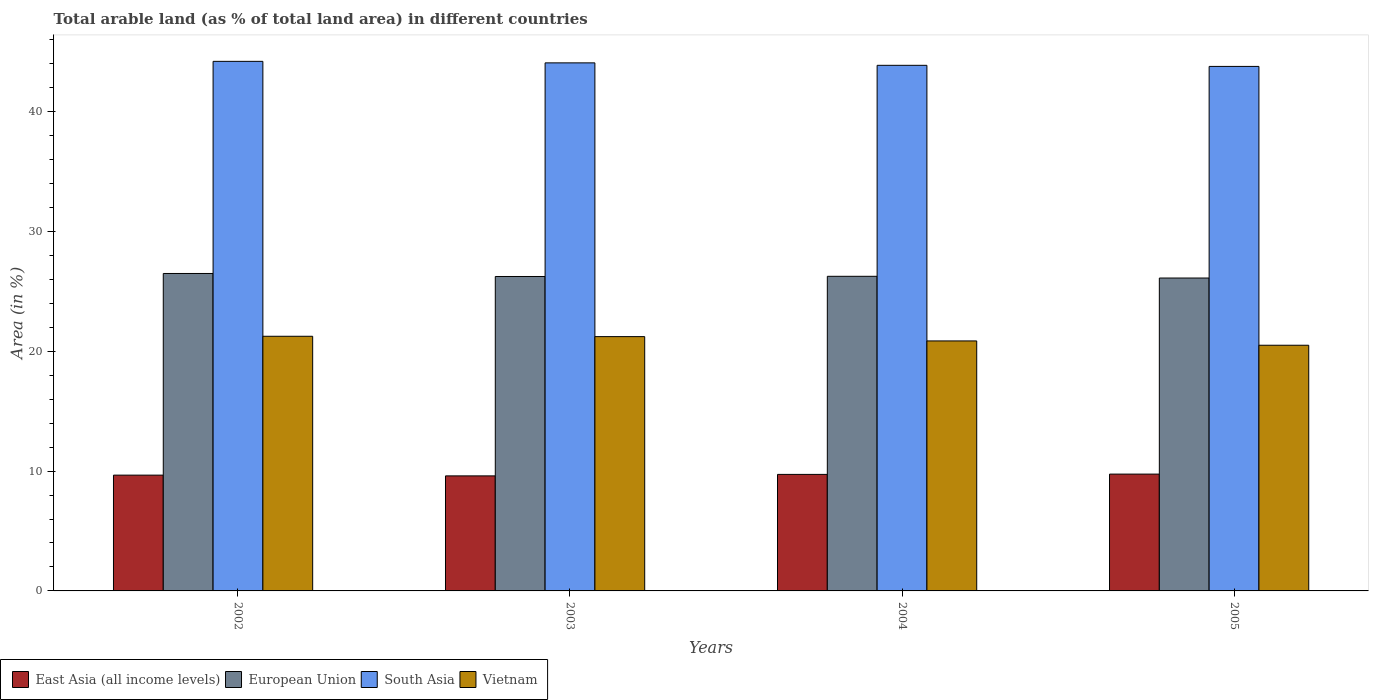How many different coloured bars are there?
Offer a very short reply. 4. How many groups of bars are there?
Keep it short and to the point. 4. Are the number of bars per tick equal to the number of legend labels?
Make the answer very short. Yes. How many bars are there on the 1st tick from the left?
Offer a very short reply. 4. What is the label of the 1st group of bars from the left?
Make the answer very short. 2002. What is the percentage of arable land in European Union in 2002?
Ensure brevity in your answer.  26.49. Across all years, what is the maximum percentage of arable land in Vietnam?
Provide a succinct answer. 21.25. Across all years, what is the minimum percentage of arable land in East Asia (all income levels)?
Offer a very short reply. 9.6. What is the total percentage of arable land in Vietnam in the graph?
Keep it short and to the point. 83.85. What is the difference between the percentage of arable land in East Asia (all income levels) in 2003 and that in 2005?
Your response must be concise. -0.15. What is the difference between the percentage of arable land in Vietnam in 2003 and the percentage of arable land in European Union in 2004?
Provide a short and direct response. -5.03. What is the average percentage of arable land in East Asia (all income levels) per year?
Keep it short and to the point. 9.69. In the year 2005, what is the difference between the percentage of arable land in East Asia (all income levels) and percentage of arable land in South Asia?
Give a very brief answer. -34.03. What is the ratio of the percentage of arable land in European Union in 2003 to that in 2005?
Your answer should be very brief. 1. Is the percentage of arable land in South Asia in 2002 less than that in 2005?
Keep it short and to the point. No. Is the difference between the percentage of arable land in East Asia (all income levels) in 2004 and 2005 greater than the difference between the percentage of arable land in South Asia in 2004 and 2005?
Your answer should be compact. No. What is the difference between the highest and the second highest percentage of arable land in South Asia?
Ensure brevity in your answer.  0.13. What is the difference between the highest and the lowest percentage of arable land in European Union?
Your response must be concise. 0.38. What does the 4th bar from the left in 2002 represents?
Keep it short and to the point. Vietnam. Is it the case that in every year, the sum of the percentage of arable land in Vietnam and percentage of arable land in East Asia (all income levels) is greater than the percentage of arable land in European Union?
Your answer should be very brief. Yes. How many bars are there?
Your answer should be compact. 16. Are all the bars in the graph horizontal?
Offer a very short reply. No. How many years are there in the graph?
Your answer should be very brief. 4. What is the difference between two consecutive major ticks on the Y-axis?
Keep it short and to the point. 10. Does the graph contain any zero values?
Your response must be concise. No. Where does the legend appear in the graph?
Make the answer very short. Bottom left. How many legend labels are there?
Keep it short and to the point. 4. What is the title of the graph?
Provide a succinct answer. Total arable land (as % of total land area) in different countries. What is the label or title of the Y-axis?
Give a very brief answer. Area (in %). What is the Area (in %) of East Asia (all income levels) in 2002?
Your answer should be compact. 9.66. What is the Area (in %) of European Union in 2002?
Offer a very short reply. 26.49. What is the Area (in %) of South Asia in 2002?
Ensure brevity in your answer.  44.2. What is the Area (in %) in Vietnam in 2002?
Give a very brief answer. 21.25. What is the Area (in %) in East Asia (all income levels) in 2003?
Offer a very short reply. 9.6. What is the Area (in %) of European Union in 2003?
Give a very brief answer. 26.24. What is the Area (in %) in South Asia in 2003?
Give a very brief answer. 44.07. What is the Area (in %) in Vietnam in 2003?
Provide a short and direct response. 21.22. What is the Area (in %) in East Asia (all income levels) in 2004?
Keep it short and to the point. 9.72. What is the Area (in %) in European Union in 2004?
Your response must be concise. 26.26. What is the Area (in %) in South Asia in 2004?
Your answer should be very brief. 43.87. What is the Area (in %) of Vietnam in 2004?
Ensure brevity in your answer.  20.86. What is the Area (in %) of East Asia (all income levels) in 2005?
Offer a very short reply. 9.75. What is the Area (in %) of European Union in 2005?
Give a very brief answer. 26.11. What is the Area (in %) of South Asia in 2005?
Keep it short and to the point. 43.78. What is the Area (in %) of Vietnam in 2005?
Your answer should be very brief. 20.51. Across all years, what is the maximum Area (in %) in East Asia (all income levels)?
Ensure brevity in your answer.  9.75. Across all years, what is the maximum Area (in %) of European Union?
Offer a terse response. 26.49. Across all years, what is the maximum Area (in %) in South Asia?
Make the answer very short. 44.2. Across all years, what is the maximum Area (in %) of Vietnam?
Give a very brief answer. 21.25. Across all years, what is the minimum Area (in %) of East Asia (all income levels)?
Your response must be concise. 9.6. Across all years, what is the minimum Area (in %) of European Union?
Offer a terse response. 26.11. Across all years, what is the minimum Area (in %) of South Asia?
Your answer should be compact. 43.78. Across all years, what is the minimum Area (in %) in Vietnam?
Make the answer very short. 20.51. What is the total Area (in %) in East Asia (all income levels) in the graph?
Your answer should be compact. 38.74. What is the total Area (in %) of European Union in the graph?
Keep it short and to the point. 105.11. What is the total Area (in %) in South Asia in the graph?
Your answer should be compact. 175.91. What is the total Area (in %) of Vietnam in the graph?
Ensure brevity in your answer.  83.85. What is the difference between the Area (in %) in East Asia (all income levels) in 2002 and that in 2003?
Your response must be concise. 0.06. What is the difference between the Area (in %) in European Union in 2002 and that in 2003?
Keep it short and to the point. 0.25. What is the difference between the Area (in %) in South Asia in 2002 and that in 2003?
Your response must be concise. 0.13. What is the difference between the Area (in %) of Vietnam in 2002 and that in 2003?
Your response must be concise. 0.03. What is the difference between the Area (in %) in East Asia (all income levels) in 2002 and that in 2004?
Your answer should be very brief. -0.06. What is the difference between the Area (in %) of European Union in 2002 and that in 2004?
Your answer should be compact. 0.24. What is the difference between the Area (in %) of South Asia in 2002 and that in 2004?
Provide a short and direct response. 0.33. What is the difference between the Area (in %) of Vietnam in 2002 and that in 2004?
Your answer should be compact. 0.39. What is the difference between the Area (in %) in East Asia (all income levels) in 2002 and that in 2005?
Your answer should be very brief. -0.09. What is the difference between the Area (in %) in European Union in 2002 and that in 2005?
Give a very brief answer. 0.38. What is the difference between the Area (in %) in South Asia in 2002 and that in 2005?
Provide a succinct answer. 0.42. What is the difference between the Area (in %) of Vietnam in 2002 and that in 2005?
Ensure brevity in your answer.  0.75. What is the difference between the Area (in %) of East Asia (all income levels) in 2003 and that in 2004?
Give a very brief answer. -0.12. What is the difference between the Area (in %) of European Union in 2003 and that in 2004?
Keep it short and to the point. -0.02. What is the difference between the Area (in %) of South Asia in 2003 and that in 2004?
Provide a short and direct response. 0.21. What is the difference between the Area (in %) of Vietnam in 2003 and that in 2004?
Ensure brevity in your answer.  0.36. What is the difference between the Area (in %) in East Asia (all income levels) in 2003 and that in 2005?
Offer a very short reply. -0.15. What is the difference between the Area (in %) in European Union in 2003 and that in 2005?
Provide a short and direct response. 0.13. What is the difference between the Area (in %) of South Asia in 2003 and that in 2005?
Provide a succinct answer. 0.3. What is the difference between the Area (in %) of Vietnam in 2003 and that in 2005?
Keep it short and to the point. 0.72. What is the difference between the Area (in %) in East Asia (all income levels) in 2004 and that in 2005?
Offer a terse response. -0.03. What is the difference between the Area (in %) of European Union in 2004 and that in 2005?
Ensure brevity in your answer.  0.14. What is the difference between the Area (in %) of South Asia in 2004 and that in 2005?
Keep it short and to the point. 0.09. What is the difference between the Area (in %) of Vietnam in 2004 and that in 2005?
Give a very brief answer. 0.36. What is the difference between the Area (in %) of East Asia (all income levels) in 2002 and the Area (in %) of European Union in 2003?
Provide a short and direct response. -16.58. What is the difference between the Area (in %) in East Asia (all income levels) in 2002 and the Area (in %) in South Asia in 2003?
Your answer should be very brief. -34.41. What is the difference between the Area (in %) of East Asia (all income levels) in 2002 and the Area (in %) of Vietnam in 2003?
Offer a very short reply. -11.56. What is the difference between the Area (in %) in European Union in 2002 and the Area (in %) in South Asia in 2003?
Keep it short and to the point. -17.58. What is the difference between the Area (in %) in European Union in 2002 and the Area (in %) in Vietnam in 2003?
Keep it short and to the point. 5.27. What is the difference between the Area (in %) in South Asia in 2002 and the Area (in %) in Vietnam in 2003?
Offer a very short reply. 22.97. What is the difference between the Area (in %) of East Asia (all income levels) in 2002 and the Area (in %) of European Union in 2004?
Your response must be concise. -16.59. What is the difference between the Area (in %) of East Asia (all income levels) in 2002 and the Area (in %) of South Asia in 2004?
Ensure brevity in your answer.  -34.2. What is the difference between the Area (in %) in East Asia (all income levels) in 2002 and the Area (in %) in Vietnam in 2004?
Your answer should be very brief. -11.2. What is the difference between the Area (in %) in European Union in 2002 and the Area (in %) in South Asia in 2004?
Provide a short and direct response. -17.37. What is the difference between the Area (in %) in European Union in 2002 and the Area (in %) in Vietnam in 2004?
Give a very brief answer. 5.63. What is the difference between the Area (in %) of South Asia in 2002 and the Area (in %) of Vietnam in 2004?
Ensure brevity in your answer.  23.33. What is the difference between the Area (in %) of East Asia (all income levels) in 2002 and the Area (in %) of European Union in 2005?
Your response must be concise. -16.45. What is the difference between the Area (in %) in East Asia (all income levels) in 2002 and the Area (in %) in South Asia in 2005?
Your answer should be very brief. -34.11. What is the difference between the Area (in %) in East Asia (all income levels) in 2002 and the Area (in %) in Vietnam in 2005?
Your response must be concise. -10.84. What is the difference between the Area (in %) in European Union in 2002 and the Area (in %) in South Asia in 2005?
Make the answer very short. -17.28. What is the difference between the Area (in %) in European Union in 2002 and the Area (in %) in Vietnam in 2005?
Your answer should be compact. 5.99. What is the difference between the Area (in %) of South Asia in 2002 and the Area (in %) of Vietnam in 2005?
Offer a terse response. 23.69. What is the difference between the Area (in %) in East Asia (all income levels) in 2003 and the Area (in %) in European Union in 2004?
Offer a very short reply. -16.66. What is the difference between the Area (in %) in East Asia (all income levels) in 2003 and the Area (in %) in South Asia in 2004?
Keep it short and to the point. -34.26. What is the difference between the Area (in %) in East Asia (all income levels) in 2003 and the Area (in %) in Vietnam in 2004?
Your answer should be very brief. -11.26. What is the difference between the Area (in %) in European Union in 2003 and the Area (in %) in South Asia in 2004?
Ensure brevity in your answer.  -17.62. What is the difference between the Area (in %) in European Union in 2003 and the Area (in %) in Vietnam in 2004?
Your answer should be very brief. 5.38. What is the difference between the Area (in %) of South Asia in 2003 and the Area (in %) of Vietnam in 2004?
Offer a terse response. 23.21. What is the difference between the Area (in %) of East Asia (all income levels) in 2003 and the Area (in %) of European Union in 2005?
Offer a terse response. -16.51. What is the difference between the Area (in %) in East Asia (all income levels) in 2003 and the Area (in %) in South Asia in 2005?
Ensure brevity in your answer.  -34.17. What is the difference between the Area (in %) of East Asia (all income levels) in 2003 and the Area (in %) of Vietnam in 2005?
Your answer should be very brief. -10.9. What is the difference between the Area (in %) of European Union in 2003 and the Area (in %) of South Asia in 2005?
Ensure brevity in your answer.  -17.53. What is the difference between the Area (in %) of European Union in 2003 and the Area (in %) of Vietnam in 2005?
Your answer should be very brief. 5.74. What is the difference between the Area (in %) of South Asia in 2003 and the Area (in %) of Vietnam in 2005?
Offer a very short reply. 23.57. What is the difference between the Area (in %) in East Asia (all income levels) in 2004 and the Area (in %) in European Union in 2005?
Your response must be concise. -16.39. What is the difference between the Area (in %) of East Asia (all income levels) in 2004 and the Area (in %) of South Asia in 2005?
Your answer should be compact. -34.05. What is the difference between the Area (in %) of East Asia (all income levels) in 2004 and the Area (in %) of Vietnam in 2005?
Give a very brief answer. -10.78. What is the difference between the Area (in %) of European Union in 2004 and the Area (in %) of South Asia in 2005?
Offer a very short reply. -17.52. What is the difference between the Area (in %) of European Union in 2004 and the Area (in %) of Vietnam in 2005?
Your answer should be very brief. 5.75. What is the difference between the Area (in %) of South Asia in 2004 and the Area (in %) of Vietnam in 2005?
Keep it short and to the point. 23.36. What is the average Area (in %) of East Asia (all income levels) per year?
Your answer should be compact. 9.69. What is the average Area (in %) in European Union per year?
Offer a very short reply. 26.28. What is the average Area (in %) in South Asia per year?
Provide a short and direct response. 43.98. What is the average Area (in %) of Vietnam per year?
Keep it short and to the point. 20.96. In the year 2002, what is the difference between the Area (in %) in East Asia (all income levels) and Area (in %) in European Union?
Keep it short and to the point. -16.83. In the year 2002, what is the difference between the Area (in %) of East Asia (all income levels) and Area (in %) of South Asia?
Provide a short and direct response. -34.53. In the year 2002, what is the difference between the Area (in %) in East Asia (all income levels) and Area (in %) in Vietnam?
Your response must be concise. -11.59. In the year 2002, what is the difference between the Area (in %) of European Union and Area (in %) of South Asia?
Your answer should be compact. -17.7. In the year 2002, what is the difference between the Area (in %) in European Union and Area (in %) in Vietnam?
Provide a succinct answer. 5.24. In the year 2002, what is the difference between the Area (in %) in South Asia and Area (in %) in Vietnam?
Offer a terse response. 22.95. In the year 2003, what is the difference between the Area (in %) in East Asia (all income levels) and Area (in %) in European Union?
Your answer should be compact. -16.64. In the year 2003, what is the difference between the Area (in %) of East Asia (all income levels) and Area (in %) of South Asia?
Offer a terse response. -34.47. In the year 2003, what is the difference between the Area (in %) in East Asia (all income levels) and Area (in %) in Vietnam?
Make the answer very short. -11.62. In the year 2003, what is the difference between the Area (in %) in European Union and Area (in %) in South Asia?
Offer a terse response. -17.83. In the year 2003, what is the difference between the Area (in %) of European Union and Area (in %) of Vietnam?
Ensure brevity in your answer.  5.02. In the year 2003, what is the difference between the Area (in %) of South Asia and Area (in %) of Vietnam?
Offer a very short reply. 22.85. In the year 2004, what is the difference between the Area (in %) in East Asia (all income levels) and Area (in %) in European Union?
Offer a terse response. -16.53. In the year 2004, what is the difference between the Area (in %) of East Asia (all income levels) and Area (in %) of South Asia?
Make the answer very short. -34.14. In the year 2004, what is the difference between the Area (in %) of East Asia (all income levels) and Area (in %) of Vietnam?
Provide a short and direct response. -11.14. In the year 2004, what is the difference between the Area (in %) of European Union and Area (in %) of South Asia?
Make the answer very short. -17.61. In the year 2004, what is the difference between the Area (in %) in European Union and Area (in %) in Vietnam?
Your response must be concise. 5.39. In the year 2004, what is the difference between the Area (in %) in South Asia and Area (in %) in Vietnam?
Provide a succinct answer. 23. In the year 2005, what is the difference between the Area (in %) in East Asia (all income levels) and Area (in %) in European Union?
Give a very brief answer. -16.36. In the year 2005, what is the difference between the Area (in %) of East Asia (all income levels) and Area (in %) of South Asia?
Your response must be concise. -34.03. In the year 2005, what is the difference between the Area (in %) in East Asia (all income levels) and Area (in %) in Vietnam?
Your answer should be compact. -10.75. In the year 2005, what is the difference between the Area (in %) in European Union and Area (in %) in South Asia?
Provide a succinct answer. -17.66. In the year 2005, what is the difference between the Area (in %) in European Union and Area (in %) in Vietnam?
Make the answer very short. 5.61. In the year 2005, what is the difference between the Area (in %) in South Asia and Area (in %) in Vietnam?
Ensure brevity in your answer.  23.27. What is the ratio of the Area (in %) in East Asia (all income levels) in 2002 to that in 2003?
Make the answer very short. 1.01. What is the ratio of the Area (in %) in European Union in 2002 to that in 2003?
Your answer should be compact. 1.01. What is the ratio of the Area (in %) in European Union in 2002 to that in 2004?
Make the answer very short. 1.01. What is the ratio of the Area (in %) in South Asia in 2002 to that in 2004?
Provide a short and direct response. 1.01. What is the ratio of the Area (in %) of Vietnam in 2002 to that in 2004?
Provide a succinct answer. 1.02. What is the ratio of the Area (in %) of European Union in 2002 to that in 2005?
Ensure brevity in your answer.  1.01. What is the ratio of the Area (in %) in South Asia in 2002 to that in 2005?
Offer a very short reply. 1.01. What is the ratio of the Area (in %) of Vietnam in 2002 to that in 2005?
Offer a terse response. 1.04. What is the ratio of the Area (in %) in East Asia (all income levels) in 2003 to that in 2004?
Offer a very short reply. 0.99. What is the ratio of the Area (in %) of European Union in 2003 to that in 2004?
Provide a succinct answer. 1. What is the ratio of the Area (in %) in South Asia in 2003 to that in 2004?
Your answer should be compact. 1. What is the ratio of the Area (in %) of Vietnam in 2003 to that in 2004?
Offer a very short reply. 1.02. What is the ratio of the Area (in %) of East Asia (all income levels) in 2003 to that in 2005?
Offer a very short reply. 0.98. What is the ratio of the Area (in %) in European Union in 2003 to that in 2005?
Provide a short and direct response. 1. What is the ratio of the Area (in %) in South Asia in 2003 to that in 2005?
Provide a short and direct response. 1.01. What is the ratio of the Area (in %) in Vietnam in 2003 to that in 2005?
Offer a very short reply. 1.04. What is the ratio of the Area (in %) in European Union in 2004 to that in 2005?
Make the answer very short. 1.01. What is the ratio of the Area (in %) of Vietnam in 2004 to that in 2005?
Your answer should be compact. 1.02. What is the difference between the highest and the second highest Area (in %) in East Asia (all income levels)?
Ensure brevity in your answer.  0.03. What is the difference between the highest and the second highest Area (in %) in European Union?
Give a very brief answer. 0.24. What is the difference between the highest and the second highest Area (in %) in South Asia?
Offer a very short reply. 0.13. What is the difference between the highest and the second highest Area (in %) of Vietnam?
Provide a succinct answer. 0.03. What is the difference between the highest and the lowest Area (in %) in East Asia (all income levels)?
Make the answer very short. 0.15. What is the difference between the highest and the lowest Area (in %) in European Union?
Your response must be concise. 0.38. What is the difference between the highest and the lowest Area (in %) of South Asia?
Make the answer very short. 0.42. What is the difference between the highest and the lowest Area (in %) in Vietnam?
Ensure brevity in your answer.  0.75. 